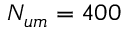<formula> <loc_0><loc_0><loc_500><loc_500>N _ { u m } = 4 0 0</formula> 